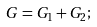Convert formula to latex. <formula><loc_0><loc_0><loc_500><loc_500>G = G _ { 1 } + G _ { 2 } ;</formula> 